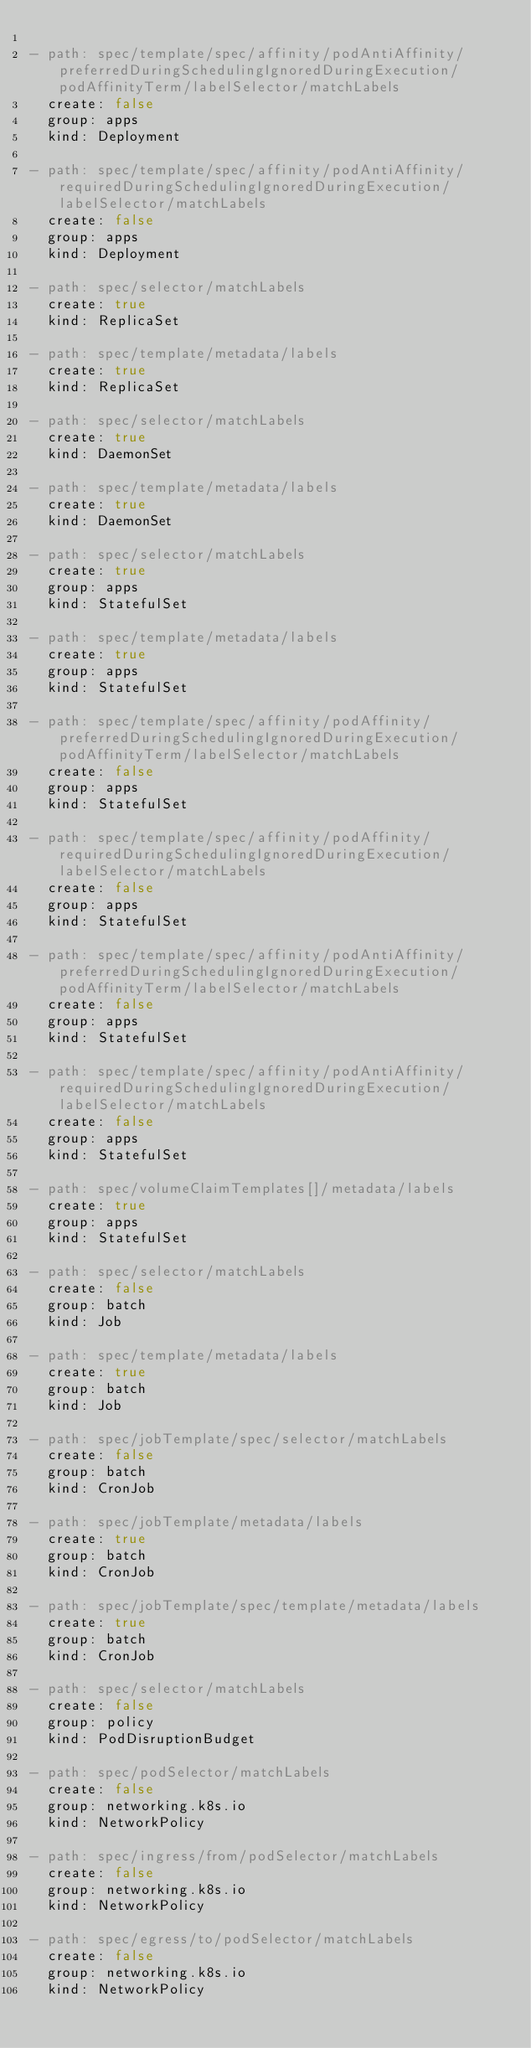<code> <loc_0><loc_0><loc_500><loc_500><_YAML_>
- path: spec/template/spec/affinity/podAntiAffinity/preferredDuringSchedulingIgnoredDuringExecution/podAffinityTerm/labelSelector/matchLabels
  create: false
  group: apps
  kind: Deployment

- path: spec/template/spec/affinity/podAntiAffinity/requiredDuringSchedulingIgnoredDuringExecution/labelSelector/matchLabels
  create: false
  group: apps
  kind: Deployment

- path: spec/selector/matchLabels
  create: true
  kind: ReplicaSet

- path: spec/template/metadata/labels
  create: true
  kind: ReplicaSet

- path: spec/selector/matchLabels
  create: true
  kind: DaemonSet

- path: spec/template/metadata/labels
  create: true
  kind: DaemonSet

- path: spec/selector/matchLabels
  create: true
  group: apps
  kind: StatefulSet

- path: spec/template/metadata/labels
  create: true
  group: apps
  kind: StatefulSet

- path: spec/template/spec/affinity/podAffinity/preferredDuringSchedulingIgnoredDuringExecution/podAffinityTerm/labelSelector/matchLabels
  create: false
  group: apps
  kind: StatefulSet

- path: spec/template/spec/affinity/podAffinity/requiredDuringSchedulingIgnoredDuringExecution/labelSelector/matchLabels
  create: false
  group: apps
  kind: StatefulSet

- path: spec/template/spec/affinity/podAntiAffinity/preferredDuringSchedulingIgnoredDuringExecution/podAffinityTerm/labelSelector/matchLabels
  create: false
  group: apps
  kind: StatefulSet

- path: spec/template/spec/affinity/podAntiAffinity/requiredDuringSchedulingIgnoredDuringExecution/labelSelector/matchLabels
  create: false
  group: apps
  kind: StatefulSet

- path: spec/volumeClaimTemplates[]/metadata/labels
  create: true
  group: apps
  kind: StatefulSet

- path: spec/selector/matchLabels
  create: false
  group: batch
  kind: Job

- path: spec/template/metadata/labels
  create: true
  group: batch
  kind: Job

- path: spec/jobTemplate/spec/selector/matchLabels
  create: false
  group: batch
  kind: CronJob

- path: spec/jobTemplate/metadata/labels
  create: true
  group: batch
  kind: CronJob

- path: spec/jobTemplate/spec/template/metadata/labels
  create: true
  group: batch
  kind: CronJob

- path: spec/selector/matchLabels
  create: false
  group: policy
  kind: PodDisruptionBudget

- path: spec/podSelector/matchLabels
  create: false
  group: networking.k8s.io
  kind: NetworkPolicy

- path: spec/ingress/from/podSelector/matchLabels
  create: false
  group: networking.k8s.io
  kind: NetworkPolicy

- path: spec/egress/to/podSelector/matchLabels
  create: false
  group: networking.k8s.io
  kind: NetworkPolicy
</code> 